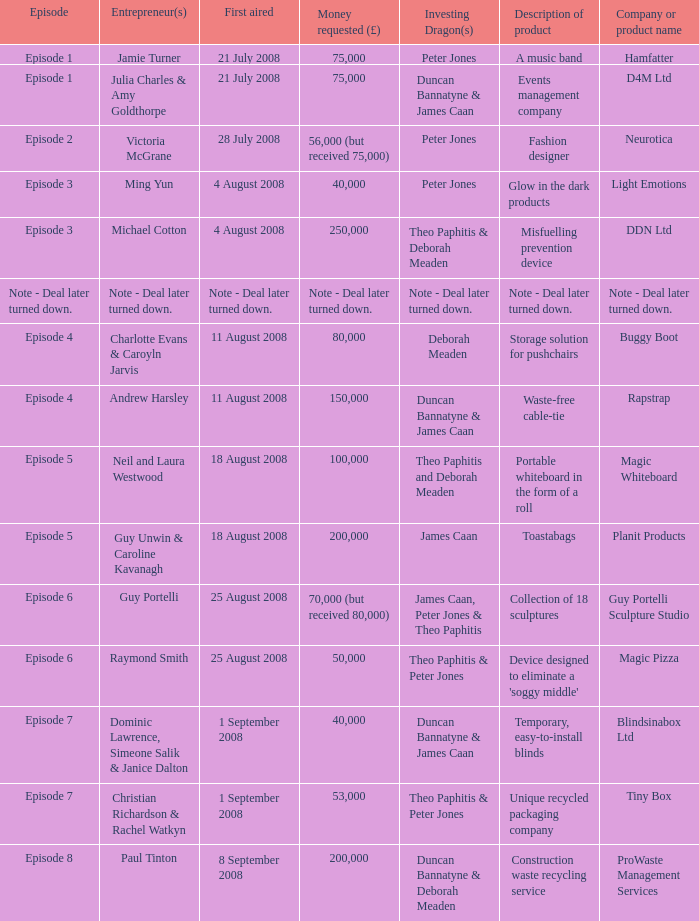Who is the company Investing Dragons, or tiny box? Theo Paphitis & Peter Jones. 